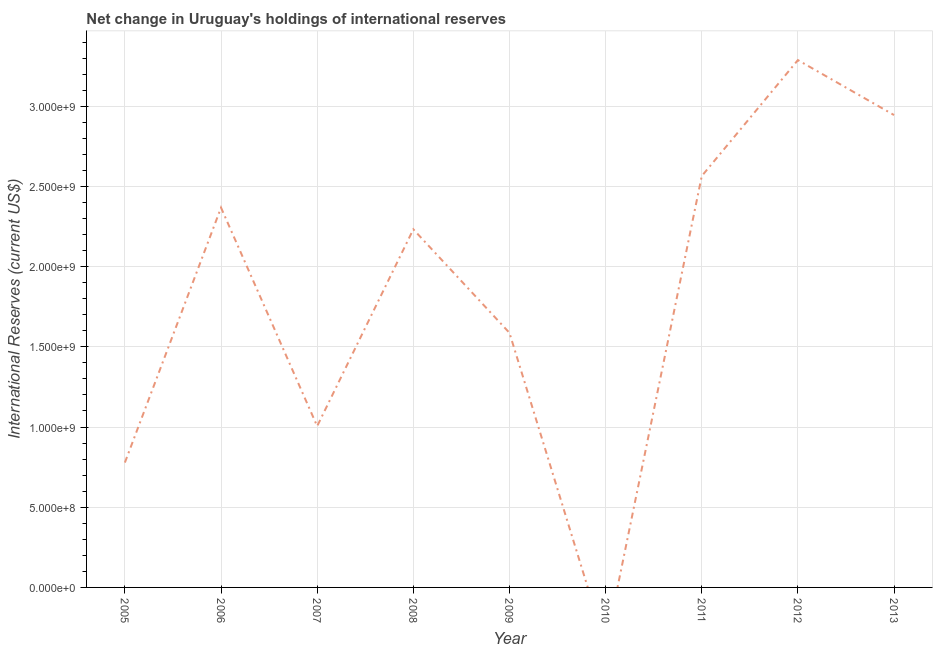What is the reserves and related items in 2006?
Provide a succinct answer. 2.37e+09. Across all years, what is the maximum reserves and related items?
Keep it short and to the point. 3.29e+09. Across all years, what is the minimum reserves and related items?
Offer a terse response. 0. In which year was the reserves and related items maximum?
Your answer should be compact. 2012. What is the sum of the reserves and related items?
Your answer should be very brief. 1.68e+1. What is the difference between the reserves and related items in 2005 and 2006?
Make the answer very short. -1.59e+09. What is the average reserves and related items per year?
Ensure brevity in your answer.  1.86e+09. What is the median reserves and related items?
Ensure brevity in your answer.  2.23e+09. What is the ratio of the reserves and related items in 2005 to that in 2011?
Your answer should be very brief. 0.3. Is the reserves and related items in 2005 less than that in 2012?
Your answer should be very brief. Yes. Is the difference between the reserves and related items in 2007 and 2012 greater than the difference between any two years?
Provide a succinct answer. No. What is the difference between the highest and the second highest reserves and related items?
Provide a short and direct response. 3.43e+08. What is the difference between the highest and the lowest reserves and related items?
Keep it short and to the point. 3.29e+09. How many lines are there?
Provide a short and direct response. 1. What is the difference between two consecutive major ticks on the Y-axis?
Ensure brevity in your answer.  5.00e+08. Does the graph contain grids?
Your answer should be compact. Yes. What is the title of the graph?
Give a very brief answer. Net change in Uruguay's holdings of international reserves. What is the label or title of the Y-axis?
Your response must be concise. International Reserves (current US$). What is the International Reserves (current US$) in 2005?
Your response must be concise. 7.78e+08. What is the International Reserves (current US$) in 2006?
Give a very brief answer. 2.37e+09. What is the International Reserves (current US$) of 2007?
Keep it short and to the point. 1.01e+09. What is the International Reserves (current US$) of 2008?
Offer a terse response. 2.23e+09. What is the International Reserves (current US$) in 2009?
Your response must be concise. 1.59e+09. What is the International Reserves (current US$) of 2010?
Offer a very short reply. 0. What is the International Reserves (current US$) of 2011?
Keep it short and to the point. 2.56e+09. What is the International Reserves (current US$) of 2012?
Offer a very short reply. 3.29e+09. What is the International Reserves (current US$) of 2013?
Your response must be concise. 2.94e+09. What is the difference between the International Reserves (current US$) in 2005 and 2006?
Make the answer very short. -1.59e+09. What is the difference between the International Reserves (current US$) in 2005 and 2007?
Keep it short and to the point. -2.27e+08. What is the difference between the International Reserves (current US$) in 2005 and 2008?
Provide a short and direct response. -1.45e+09. What is the difference between the International Reserves (current US$) in 2005 and 2009?
Offer a very short reply. -8.09e+08. What is the difference between the International Reserves (current US$) in 2005 and 2011?
Your answer should be very brief. -1.79e+09. What is the difference between the International Reserves (current US$) in 2005 and 2012?
Offer a terse response. -2.51e+09. What is the difference between the International Reserves (current US$) in 2005 and 2013?
Your answer should be very brief. -2.17e+09. What is the difference between the International Reserves (current US$) in 2006 and 2007?
Keep it short and to the point. 1.36e+09. What is the difference between the International Reserves (current US$) in 2006 and 2008?
Your answer should be compact. 1.35e+08. What is the difference between the International Reserves (current US$) in 2006 and 2009?
Your answer should be compact. 7.81e+08. What is the difference between the International Reserves (current US$) in 2006 and 2011?
Your response must be concise. -1.97e+08. What is the difference between the International Reserves (current US$) in 2006 and 2012?
Offer a terse response. -9.20e+08. What is the difference between the International Reserves (current US$) in 2006 and 2013?
Give a very brief answer. -5.77e+08. What is the difference between the International Reserves (current US$) in 2007 and 2008?
Offer a very short reply. -1.23e+09. What is the difference between the International Reserves (current US$) in 2007 and 2009?
Your response must be concise. -5.81e+08. What is the difference between the International Reserves (current US$) in 2007 and 2011?
Provide a short and direct response. -1.56e+09. What is the difference between the International Reserves (current US$) in 2007 and 2012?
Your answer should be very brief. -2.28e+09. What is the difference between the International Reserves (current US$) in 2007 and 2013?
Your answer should be very brief. -1.94e+09. What is the difference between the International Reserves (current US$) in 2008 and 2009?
Keep it short and to the point. 6.45e+08. What is the difference between the International Reserves (current US$) in 2008 and 2011?
Make the answer very short. -3.32e+08. What is the difference between the International Reserves (current US$) in 2008 and 2012?
Your response must be concise. -1.05e+09. What is the difference between the International Reserves (current US$) in 2008 and 2013?
Give a very brief answer. -7.12e+08. What is the difference between the International Reserves (current US$) in 2009 and 2011?
Keep it short and to the point. -9.77e+08. What is the difference between the International Reserves (current US$) in 2009 and 2012?
Offer a terse response. -1.70e+09. What is the difference between the International Reserves (current US$) in 2009 and 2013?
Give a very brief answer. -1.36e+09. What is the difference between the International Reserves (current US$) in 2011 and 2012?
Offer a very short reply. -7.23e+08. What is the difference between the International Reserves (current US$) in 2011 and 2013?
Make the answer very short. -3.80e+08. What is the difference between the International Reserves (current US$) in 2012 and 2013?
Your answer should be compact. 3.43e+08. What is the ratio of the International Reserves (current US$) in 2005 to that in 2006?
Offer a very short reply. 0.33. What is the ratio of the International Reserves (current US$) in 2005 to that in 2007?
Make the answer very short. 0.77. What is the ratio of the International Reserves (current US$) in 2005 to that in 2008?
Your answer should be very brief. 0.35. What is the ratio of the International Reserves (current US$) in 2005 to that in 2009?
Offer a terse response. 0.49. What is the ratio of the International Reserves (current US$) in 2005 to that in 2011?
Give a very brief answer. 0.3. What is the ratio of the International Reserves (current US$) in 2005 to that in 2012?
Make the answer very short. 0.24. What is the ratio of the International Reserves (current US$) in 2005 to that in 2013?
Your response must be concise. 0.26. What is the ratio of the International Reserves (current US$) in 2006 to that in 2007?
Keep it short and to the point. 2.35. What is the ratio of the International Reserves (current US$) in 2006 to that in 2008?
Your answer should be very brief. 1.06. What is the ratio of the International Reserves (current US$) in 2006 to that in 2009?
Provide a succinct answer. 1.49. What is the ratio of the International Reserves (current US$) in 2006 to that in 2011?
Give a very brief answer. 0.92. What is the ratio of the International Reserves (current US$) in 2006 to that in 2012?
Your response must be concise. 0.72. What is the ratio of the International Reserves (current US$) in 2006 to that in 2013?
Your response must be concise. 0.8. What is the ratio of the International Reserves (current US$) in 2007 to that in 2008?
Provide a short and direct response. 0.45. What is the ratio of the International Reserves (current US$) in 2007 to that in 2009?
Keep it short and to the point. 0.63. What is the ratio of the International Reserves (current US$) in 2007 to that in 2011?
Provide a succinct answer. 0.39. What is the ratio of the International Reserves (current US$) in 2007 to that in 2012?
Make the answer very short. 0.31. What is the ratio of the International Reserves (current US$) in 2007 to that in 2013?
Offer a terse response. 0.34. What is the ratio of the International Reserves (current US$) in 2008 to that in 2009?
Your answer should be compact. 1.41. What is the ratio of the International Reserves (current US$) in 2008 to that in 2011?
Keep it short and to the point. 0.87. What is the ratio of the International Reserves (current US$) in 2008 to that in 2012?
Ensure brevity in your answer.  0.68. What is the ratio of the International Reserves (current US$) in 2008 to that in 2013?
Offer a terse response. 0.76. What is the ratio of the International Reserves (current US$) in 2009 to that in 2011?
Give a very brief answer. 0.62. What is the ratio of the International Reserves (current US$) in 2009 to that in 2012?
Keep it short and to the point. 0.48. What is the ratio of the International Reserves (current US$) in 2009 to that in 2013?
Keep it short and to the point. 0.54. What is the ratio of the International Reserves (current US$) in 2011 to that in 2012?
Make the answer very short. 0.78. What is the ratio of the International Reserves (current US$) in 2011 to that in 2013?
Provide a short and direct response. 0.87. What is the ratio of the International Reserves (current US$) in 2012 to that in 2013?
Offer a very short reply. 1.12. 